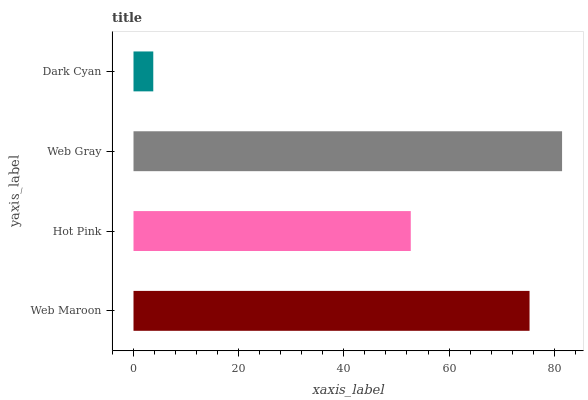Is Dark Cyan the minimum?
Answer yes or no. Yes. Is Web Gray the maximum?
Answer yes or no. Yes. Is Hot Pink the minimum?
Answer yes or no. No. Is Hot Pink the maximum?
Answer yes or no. No. Is Web Maroon greater than Hot Pink?
Answer yes or no. Yes. Is Hot Pink less than Web Maroon?
Answer yes or no. Yes. Is Hot Pink greater than Web Maroon?
Answer yes or no. No. Is Web Maroon less than Hot Pink?
Answer yes or no. No. Is Web Maroon the high median?
Answer yes or no. Yes. Is Hot Pink the low median?
Answer yes or no. Yes. Is Hot Pink the high median?
Answer yes or no. No. Is Web Maroon the low median?
Answer yes or no. No. 